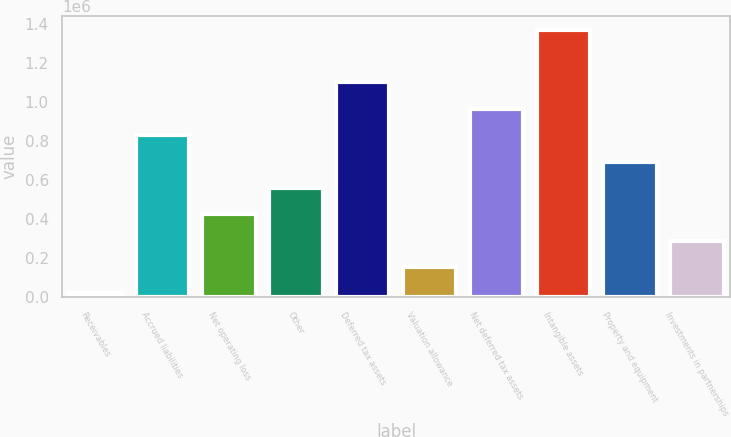Convert chart to OTSL. <chart><loc_0><loc_0><loc_500><loc_500><bar_chart><fcel>Receivables<fcel>Accrued liabilities<fcel>Net operating loss<fcel>Other<fcel>Deferred tax assets<fcel>Valuation allowance<fcel>Net deferred tax assets<fcel>Intangible assets<fcel>Property and equipment<fcel>Investments in partnerships<nl><fcel>19283<fcel>829074<fcel>424178<fcel>559143<fcel>1.099e+06<fcel>154248<fcel>964039<fcel>1.36893e+06<fcel>694108<fcel>289213<nl></chart> 